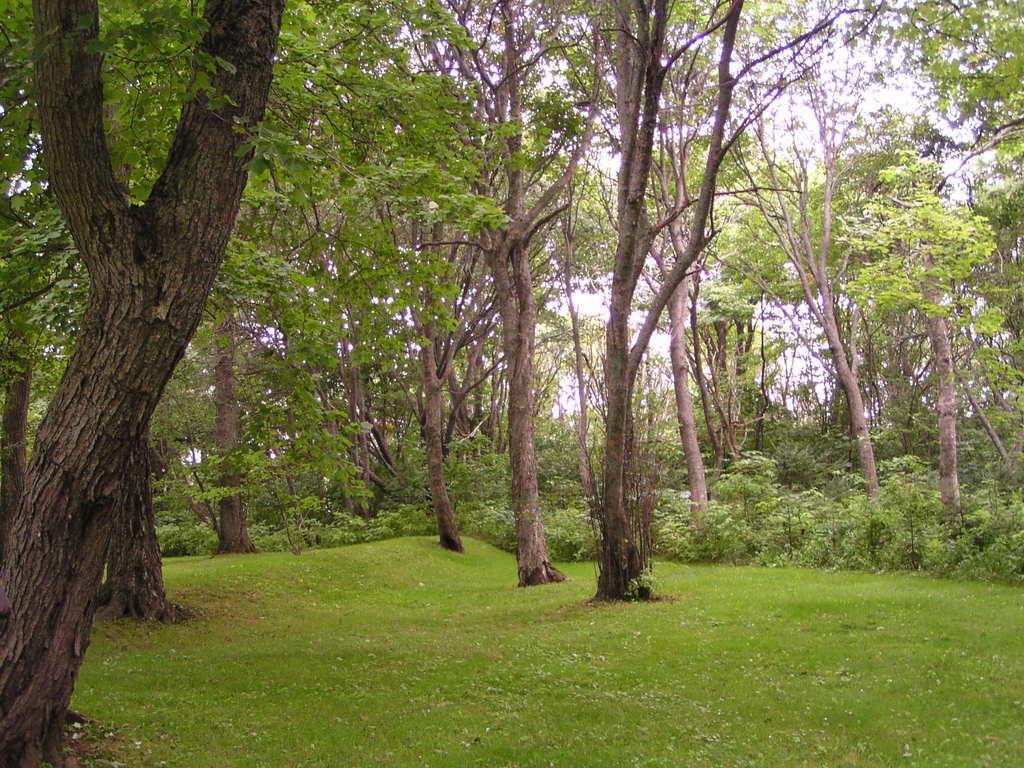Could you give a brief overview of what you see in this image? In this picture we can see grass, trees and in the background we can see the sky. 